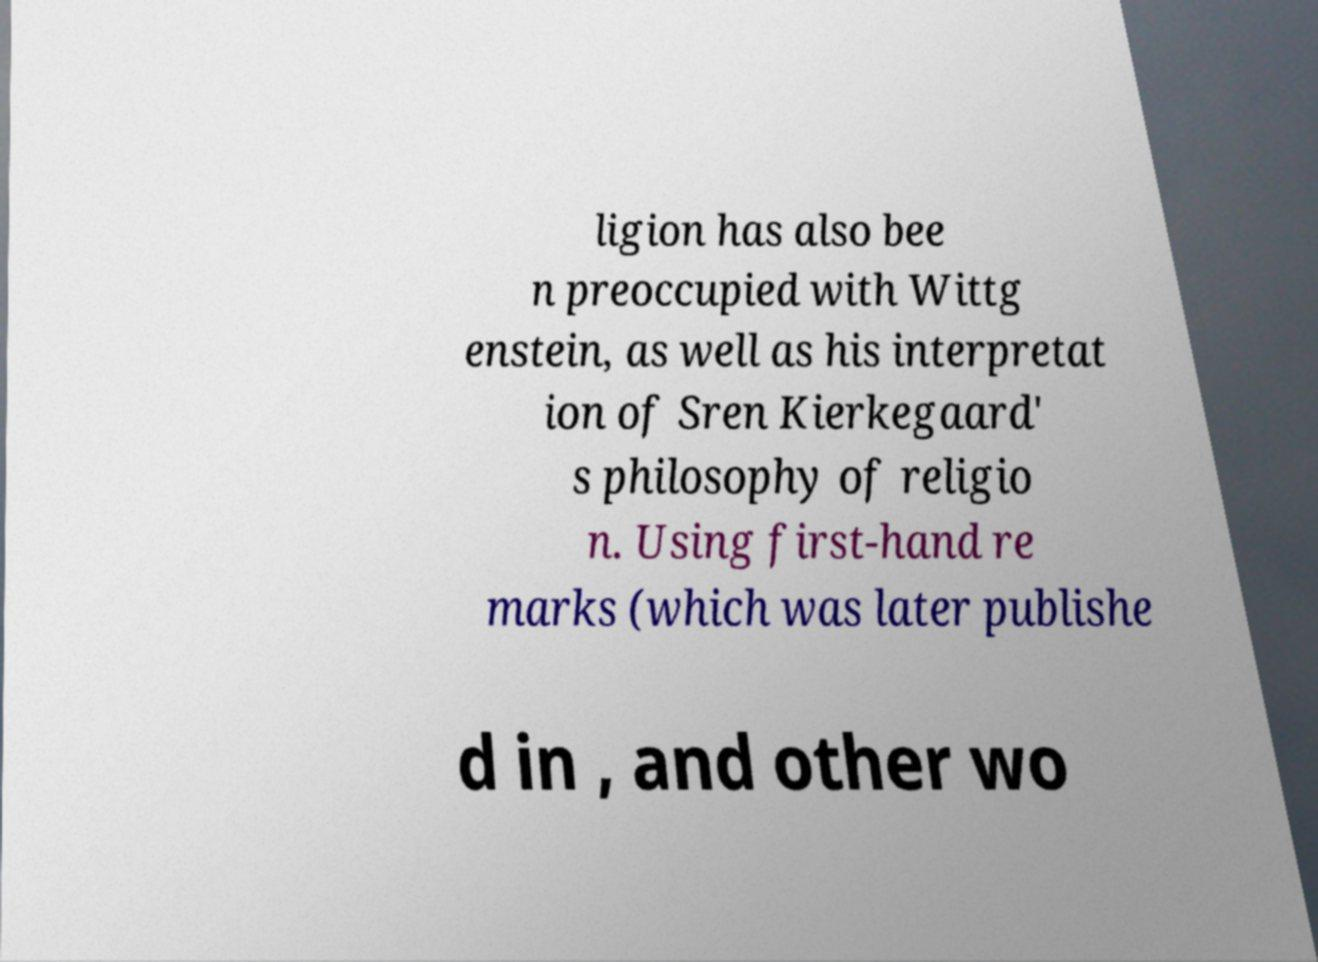Could you extract and type out the text from this image? ligion has also bee n preoccupied with Wittg enstein, as well as his interpretat ion of Sren Kierkegaard' s philosophy of religio n. Using first-hand re marks (which was later publishe d in , and other wo 